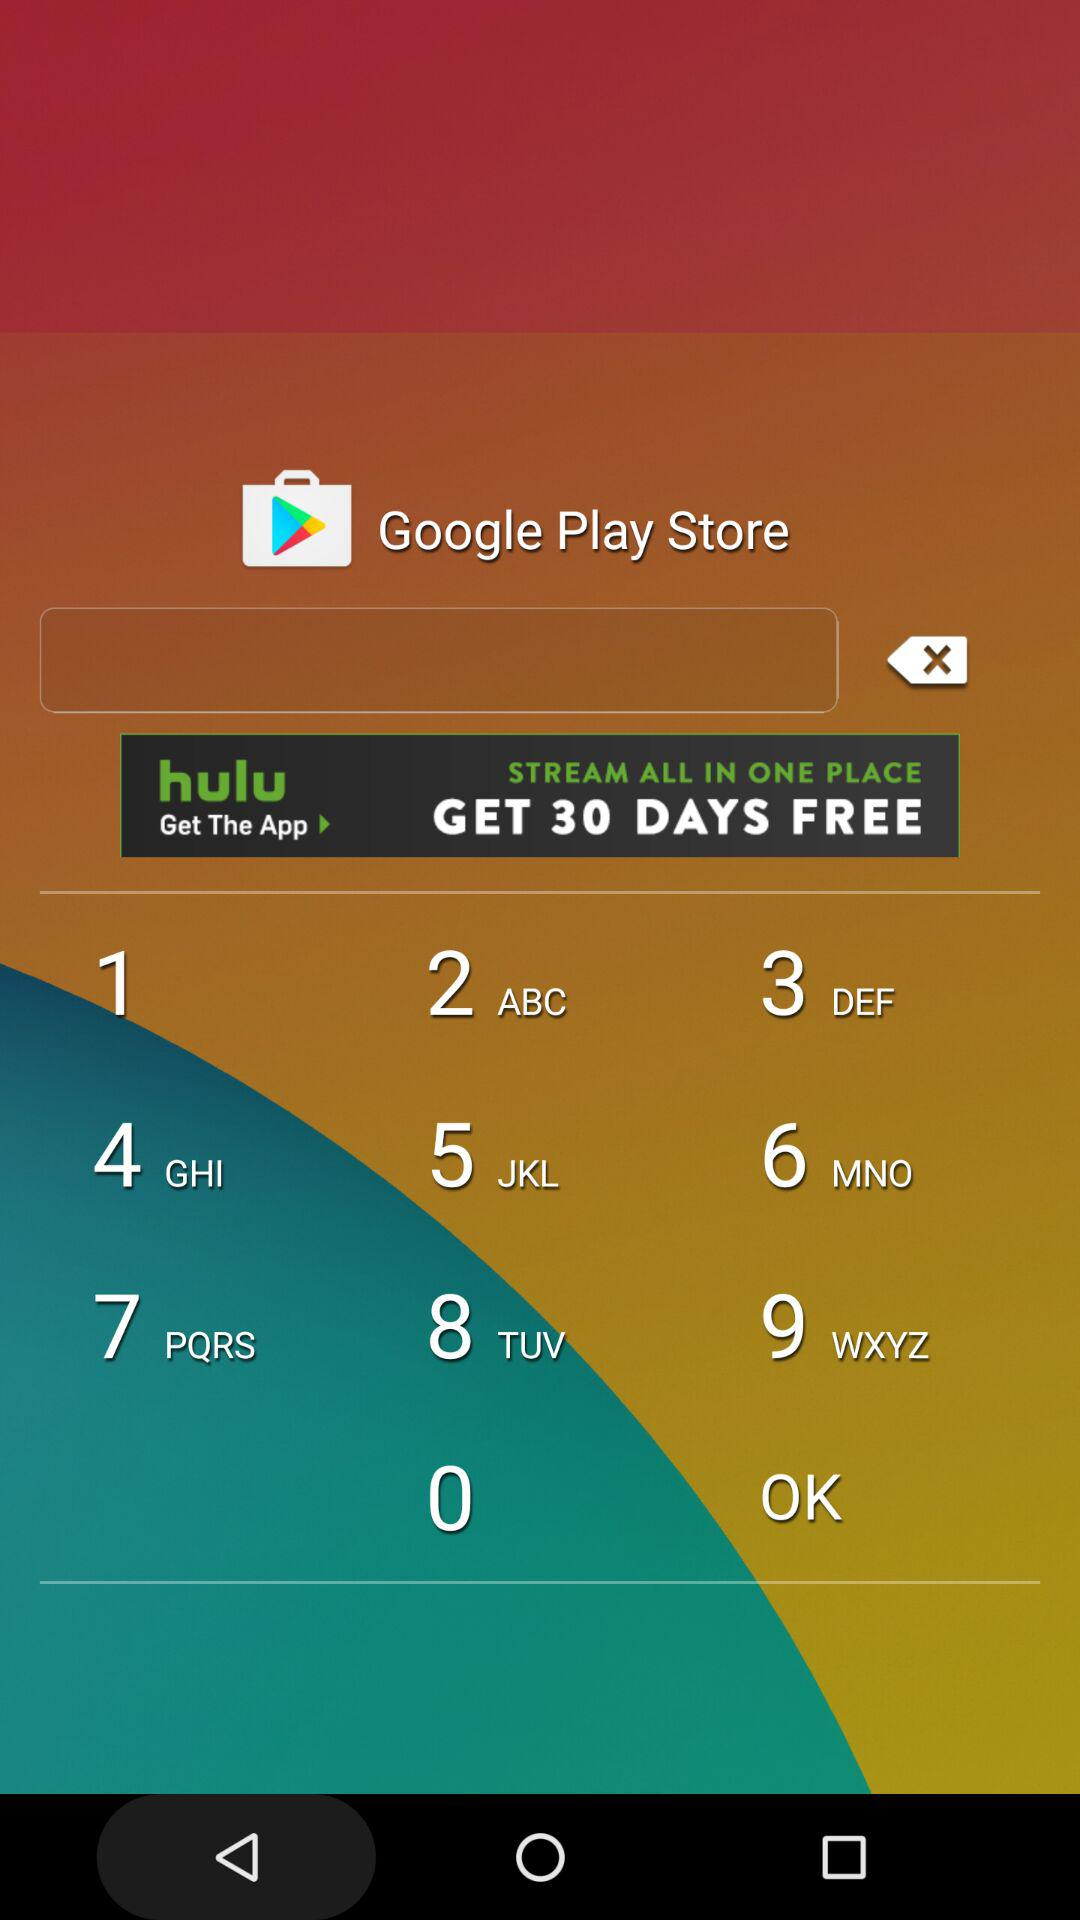Which day of the week is March 27?
When the provided information is insufficient, respond with <no answer>. <no answer> 